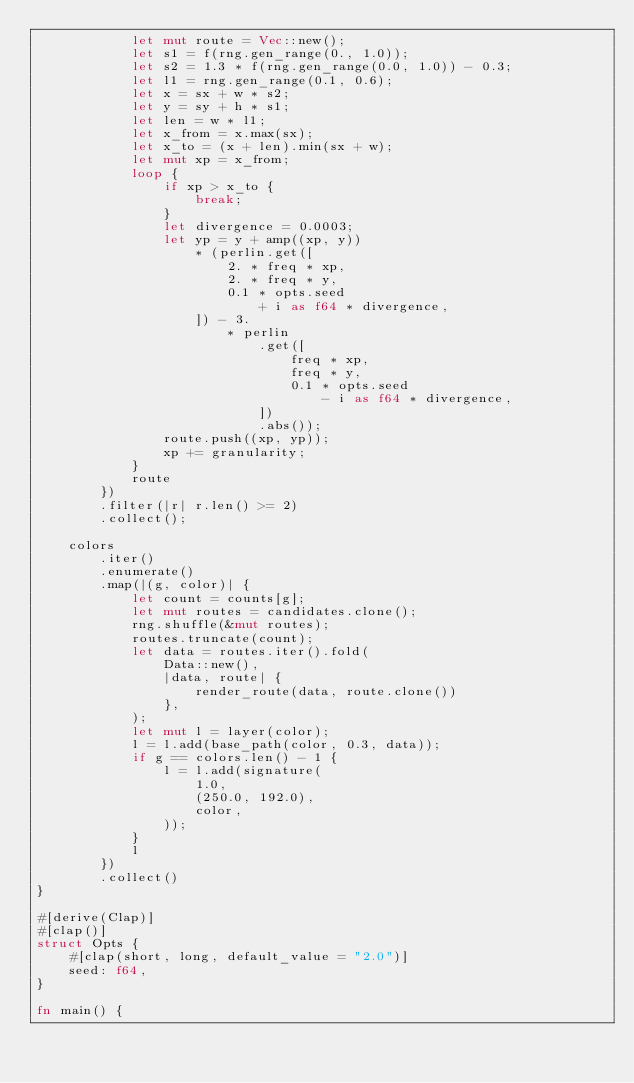<code> <loc_0><loc_0><loc_500><loc_500><_Rust_>            let mut route = Vec::new();
            let s1 = f(rng.gen_range(0., 1.0));
            let s2 = 1.3 * f(rng.gen_range(0.0, 1.0)) - 0.3;
            let l1 = rng.gen_range(0.1, 0.6);
            let x = sx + w * s2;
            let y = sy + h * s1;
            let len = w * l1;
            let x_from = x.max(sx);
            let x_to = (x + len).min(sx + w);
            let mut xp = x_from;
            loop {
                if xp > x_to {
                    break;
                }
                let divergence = 0.0003;
                let yp = y + amp((xp, y))
                    * (perlin.get([
                        2. * freq * xp,
                        2. * freq * y,
                        0.1 * opts.seed
                            + i as f64 * divergence,
                    ]) - 3.
                        * perlin
                            .get([
                                freq * xp,
                                freq * y,
                                0.1 * opts.seed
                                    - i as f64 * divergence,
                            ])
                            .abs());
                route.push((xp, yp));
                xp += granularity;
            }
            route
        })
        .filter(|r| r.len() >= 2)
        .collect();

    colors
        .iter()
        .enumerate()
        .map(|(g, color)| {
            let count = counts[g];
            let mut routes = candidates.clone();
            rng.shuffle(&mut routes);
            routes.truncate(count);
            let data = routes.iter().fold(
                Data::new(),
                |data, route| {
                    render_route(data, route.clone())
                },
            );
            let mut l = layer(color);
            l = l.add(base_path(color, 0.3, data));
            if g == colors.len() - 1 {
                l = l.add(signature(
                    1.0,
                    (250.0, 192.0),
                    color,
                ));
            }
            l
        })
        .collect()
}

#[derive(Clap)]
#[clap()]
struct Opts {
    #[clap(short, long, default_value = "2.0")]
    seed: f64,
}

fn main() {</code> 